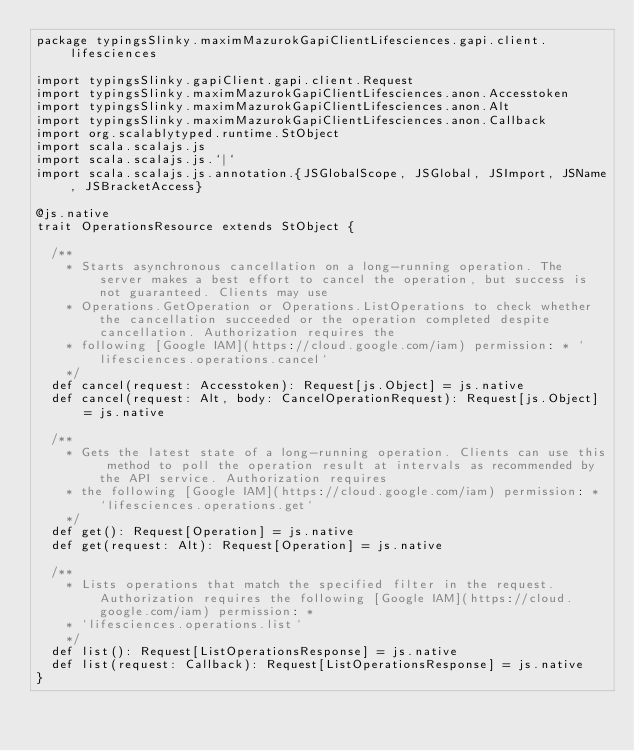Convert code to text. <code><loc_0><loc_0><loc_500><loc_500><_Scala_>package typingsSlinky.maximMazurokGapiClientLifesciences.gapi.client.lifesciences

import typingsSlinky.gapiClient.gapi.client.Request
import typingsSlinky.maximMazurokGapiClientLifesciences.anon.Accesstoken
import typingsSlinky.maximMazurokGapiClientLifesciences.anon.Alt
import typingsSlinky.maximMazurokGapiClientLifesciences.anon.Callback
import org.scalablytyped.runtime.StObject
import scala.scalajs.js
import scala.scalajs.js.`|`
import scala.scalajs.js.annotation.{JSGlobalScope, JSGlobal, JSImport, JSName, JSBracketAccess}

@js.native
trait OperationsResource extends StObject {
  
  /**
    * Starts asynchronous cancellation on a long-running operation. The server makes a best effort to cancel the operation, but success is not guaranteed. Clients may use
    * Operations.GetOperation or Operations.ListOperations to check whether the cancellation succeeded or the operation completed despite cancellation. Authorization requires the
    * following [Google IAM](https://cloud.google.com/iam) permission: * `lifesciences.operations.cancel`
    */
  def cancel(request: Accesstoken): Request[js.Object] = js.native
  def cancel(request: Alt, body: CancelOperationRequest): Request[js.Object] = js.native
  
  /**
    * Gets the latest state of a long-running operation. Clients can use this method to poll the operation result at intervals as recommended by the API service. Authorization requires
    * the following [Google IAM](https://cloud.google.com/iam) permission: * `lifesciences.operations.get`
    */
  def get(): Request[Operation] = js.native
  def get(request: Alt): Request[Operation] = js.native
  
  /**
    * Lists operations that match the specified filter in the request. Authorization requires the following [Google IAM](https://cloud.google.com/iam) permission: *
    * `lifesciences.operations.list`
    */
  def list(): Request[ListOperationsResponse] = js.native
  def list(request: Callback): Request[ListOperationsResponse] = js.native
}
</code> 